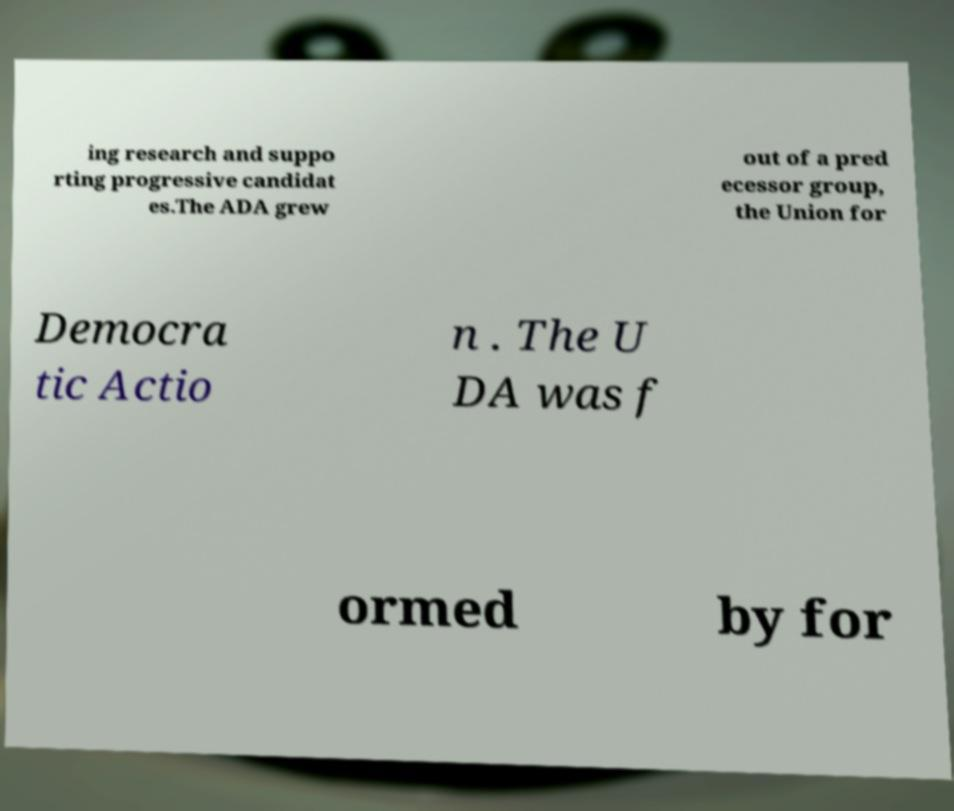For documentation purposes, I need the text within this image transcribed. Could you provide that? ing research and suppo rting progressive candidat es.The ADA grew out of a pred ecessor group, the Union for Democra tic Actio n . The U DA was f ormed by for 